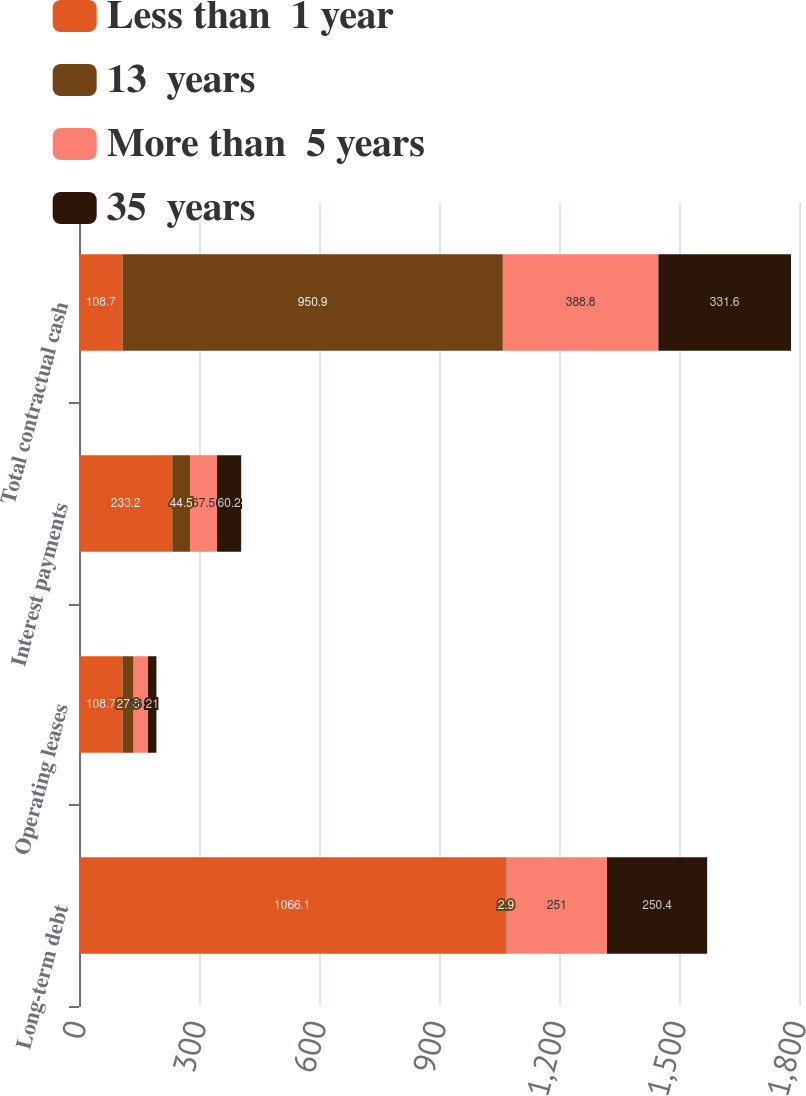Convert chart to OTSL. <chart><loc_0><loc_0><loc_500><loc_500><stacked_bar_chart><ecel><fcel>Long-term debt<fcel>Operating leases<fcel>Interest payments<fcel>Total contractual cash<nl><fcel>Less than  1 year<fcel>1066.1<fcel>108.7<fcel>233.2<fcel>108.7<nl><fcel>13  years<fcel>2.9<fcel>27.8<fcel>44.5<fcel>950.9<nl><fcel>More than  5 years<fcel>251<fcel>36.1<fcel>67.5<fcel>388.8<nl><fcel>35  years<fcel>250.4<fcel>21<fcel>60.2<fcel>331.6<nl></chart> 